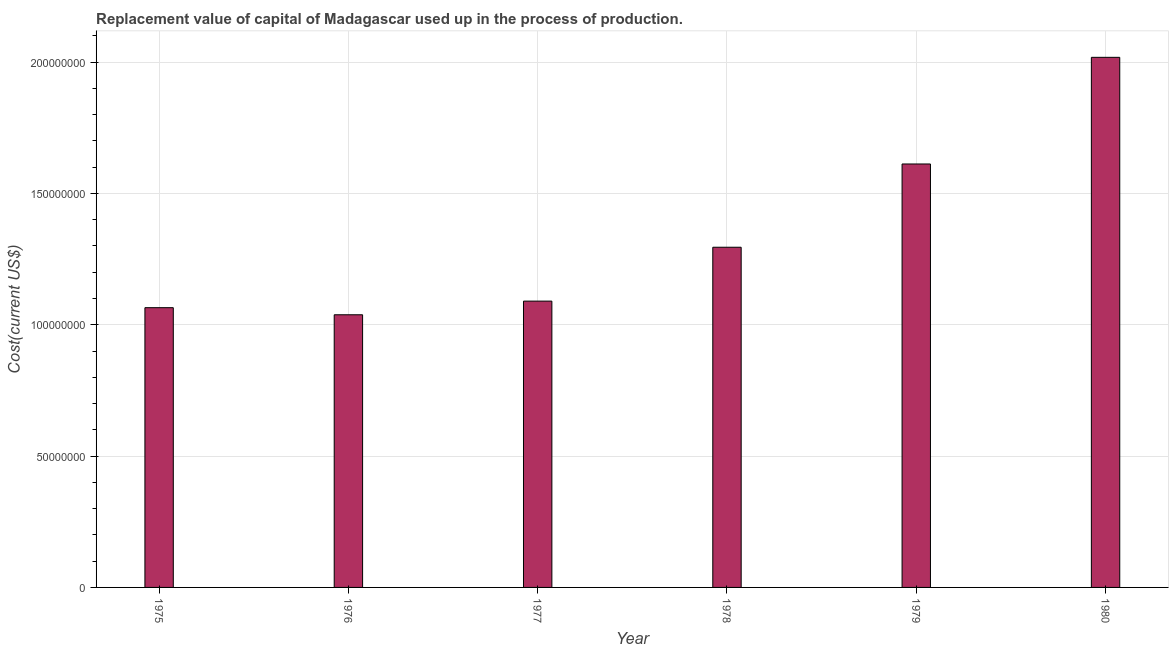Does the graph contain any zero values?
Provide a short and direct response. No. Does the graph contain grids?
Your answer should be compact. Yes. What is the title of the graph?
Make the answer very short. Replacement value of capital of Madagascar used up in the process of production. What is the label or title of the Y-axis?
Ensure brevity in your answer.  Cost(current US$). What is the consumption of fixed capital in 1976?
Keep it short and to the point. 1.04e+08. Across all years, what is the maximum consumption of fixed capital?
Your response must be concise. 2.02e+08. Across all years, what is the minimum consumption of fixed capital?
Provide a succinct answer. 1.04e+08. In which year was the consumption of fixed capital maximum?
Ensure brevity in your answer.  1980. In which year was the consumption of fixed capital minimum?
Offer a terse response. 1976. What is the sum of the consumption of fixed capital?
Ensure brevity in your answer.  8.12e+08. What is the difference between the consumption of fixed capital in 1976 and 1978?
Make the answer very short. -2.57e+07. What is the average consumption of fixed capital per year?
Provide a short and direct response. 1.35e+08. What is the median consumption of fixed capital?
Give a very brief answer. 1.19e+08. What is the ratio of the consumption of fixed capital in 1975 to that in 1979?
Your response must be concise. 0.66. What is the difference between the highest and the second highest consumption of fixed capital?
Provide a succinct answer. 4.06e+07. Is the sum of the consumption of fixed capital in 1975 and 1976 greater than the maximum consumption of fixed capital across all years?
Provide a short and direct response. Yes. What is the difference between the highest and the lowest consumption of fixed capital?
Provide a succinct answer. 9.80e+07. In how many years, is the consumption of fixed capital greater than the average consumption of fixed capital taken over all years?
Provide a short and direct response. 2. What is the difference between two consecutive major ticks on the Y-axis?
Keep it short and to the point. 5.00e+07. Are the values on the major ticks of Y-axis written in scientific E-notation?
Keep it short and to the point. No. What is the Cost(current US$) of 1975?
Your answer should be compact. 1.07e+08. What is the Cost(current US$) in 1976?
Keep it short and to the point. 1.04e+08. What is the Cost(current US$) in 1977?
Keep it short and to the point. 1.09e+08. What is the Cost(current US$) of 1978?
Keep it short and to the point. 1.30e+08. What is the Cost(current US$) in 1979?
Keep it short and to the point. 1.61e+08. What is the Cost(current US$) of 1980?
Your response must be concise. 2.02e+08. What is the difference between the Cost(current US$) in 1975 and 1976?
Offer a terse response. 2.70e+06. What is the difference between the Cost(current US$) in 1975 and 1977?
Keep it short and to the point. -2.50e+06. What is the difference between the Cost(current US$) in 1975 and 1978?
Make the answer very short. -2.30e+07. What is the difference between the Cost(current US$) in 1975 and 1979?
Your answer should be compact. -5.47e+07. What is the difference between the Cost(current US$) in 1975 and 1980?
Offer a very short reply. -9.53e+07. What is the difference between the Cost(current US$) in 1976 and 1977?
Make the answer very short. -5.20e+06. What is the difference between the Cost(current US$) in 1976 and 1978?
Your response must be concise. -2.57e+07. What is the difference between the Cost(current US$) in 1976 and 1979?
Make the answer very short. -5.74e+07. What is the difference between the Cost(current US$) in 1976 and 1980?
Your response must be concise. -9.80e+07. What is the difference between the Cost(current US$) in 1977 and 1978?
Give a very brief answer. -2.05e+07. What is the difference between the Cost(current US$) in 1977 and 1979?
Provide a succinct answer. -5.22e+07. What is the difference between the Cost(current US$) in 1977 and 1980?
Your answer should be very brief. -9.28e+07. What is the difference between the Cost(current US$) in 1978 and 1979?
Your answer should be compact. -3.17e+07. What is the difference between the Cost(current US$) in 1978 and 1980?
Provide a succinct answer. -7.23e+07. What is the difference between the Cost(current US$) in 1979 and 1980?
Give a very brief answer. -4.06e+07. What is the ratio of the Cost(current US$) in 1975 to that in 1977?
Provide a succinct answer. 0.98. What is the ratio of the Cost(current US$) in 1975 to that in 1978?
Your response must be concise. 0.82. What is the ratio of the Cost(current US$) in 1975 to that in 1979?
Keep it short and to the point. 0.66. What is the ratio of the Cost(current US$) in 1975 to that in 1980?
Your response must be concise. 0.53. What is the ratio of the Cost(current US$) in 1976 to that in 1977?
Provide a short and direct response. 0.95. What is the ratio of the Cost(current US$) in 1976 to that in 1978?
Your answer should be very brief. 0.8. What is the ratio of the Cost(current US$) in 1976 to that in 1979?
Ensure brevity in your answer.  0.64. What is the ratio of the Cost(current US$) in 1976 to that in 1980?
Make the answer very short. 0.51. What is the ratio of the Cost(current US$) in 1977 to that in 1978?
Ensure brevity in your answer.  0.84. What is the ratio of the Cost(current US$) in 1977 to that in 1979?
Your response must be concise. 0.68. What is the ratio of the Cost(current US$) in 1977 to that in 1980?
Make the answer very short. 0.54. What is the ratio of the Cost(current US$) in 1978 to that in 1979?
Give a very brief answer. 0.8. What is the ratio of the Cost(current US$) in 1978 to that in 1980?
Provide a succinct answer. 0.64. What is the ratio of the Cost(current US$) in 1979 to that in 1980?
Give a very brief answer. 0.8. 